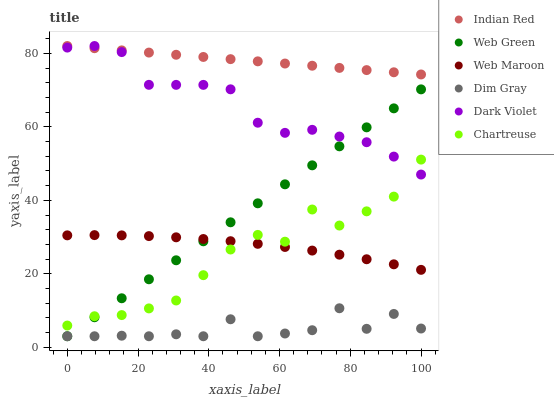Does Dim Gray have the minimum area under the curve?
Answer yes or no. Yes. Does Indian Red have the maximum area under the curve?
Answer yes or no. Yes. Does Web Maroon have the minimum area under the curve?
Answer yes or no. No. Does Web Maroon have the maximum area under the curve?
Answer yes or no. No. Is Web Green the smoothest?
Answer yes or no. Yes. Is Dim Gray the roughest?
Answer yes or no. Yes. Is Web Maroon the smoothest?
Answer yes or no. No. Is Web Maroon the roughest?
Answer yes or no. No. Does Dim Gray have the lowest value?
Answer yes or no. Yes. Does Web Maroon have the lowest value?
Answer yes or no. No. Does Indian Red have the highest value?
Answer yes or no. Yes. Does Web Maroon have the highest value?
Answer yes or no. No. Is Dim Gray less than Dark Violet?
Answer yes or no. Yes. Is Web Maroon greater than Dim Gray?
Answer yes or no. Yes. Does Dim Gray intersect Web Green?
Answer yes or no. Yes. Is Dim Gray less than Web Green?
Answer yes or no. No. Is Dim Gray greater than Web Green?
Answer yes or no. No. Does Dim Gray intersect Dark Violet?
Answer yes or no. No. 